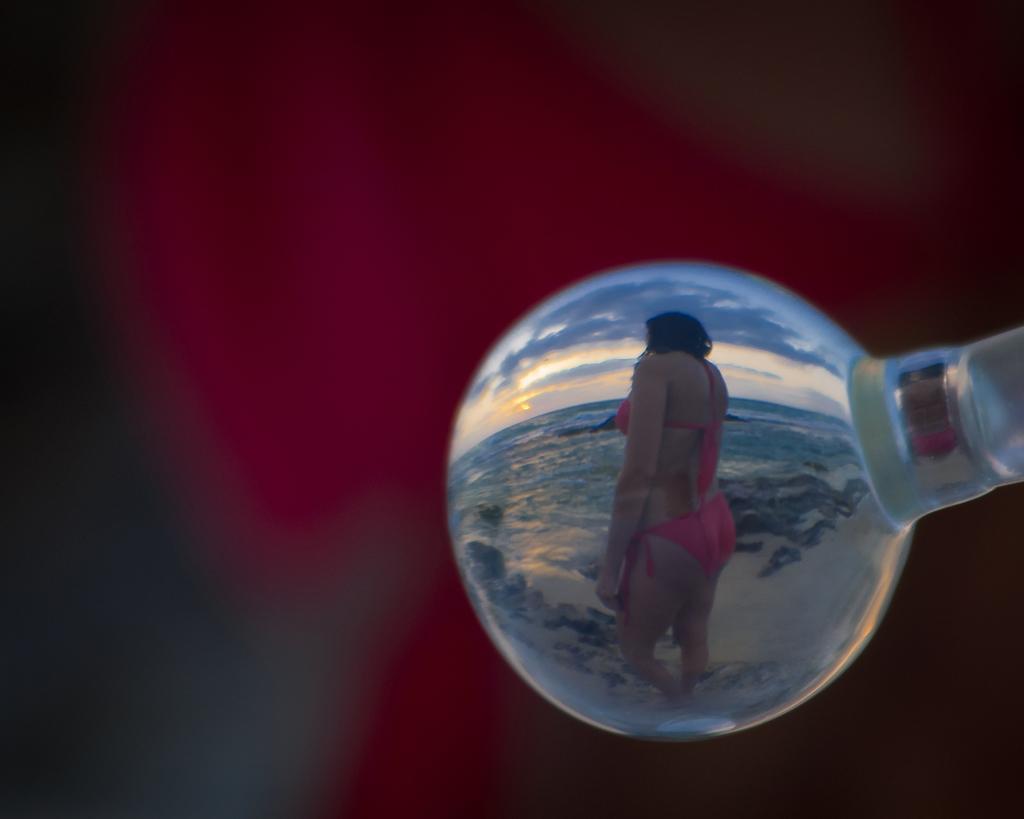Can you describe this image briefly? In this image I can see a white color object. Inside the object I can see a person and the water. The sky is in blue and white. Background is blurred. 